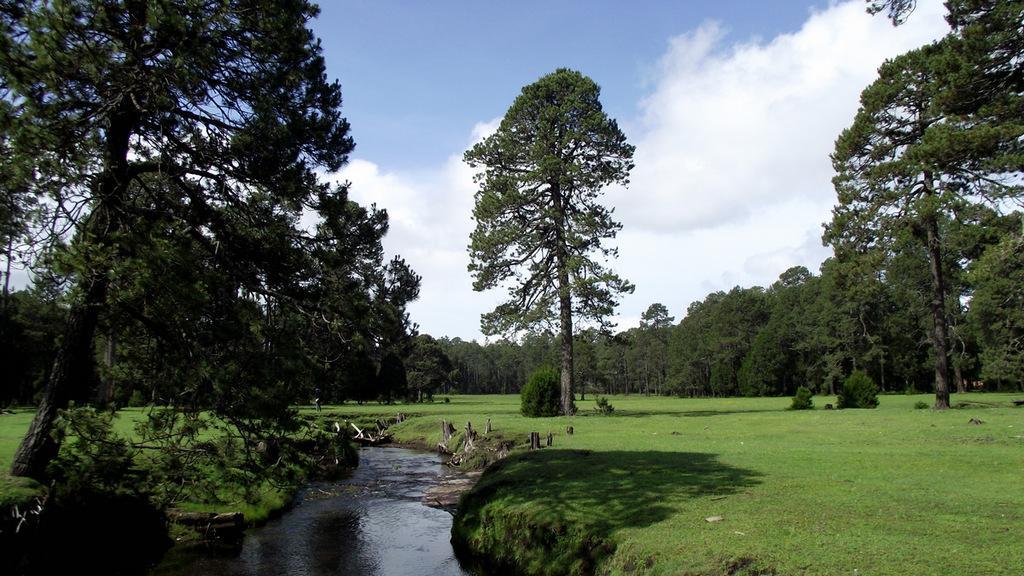Describe this image in one or two sentences. In this image we can see call, logs, ground, trees and sky with clouds in the background. 